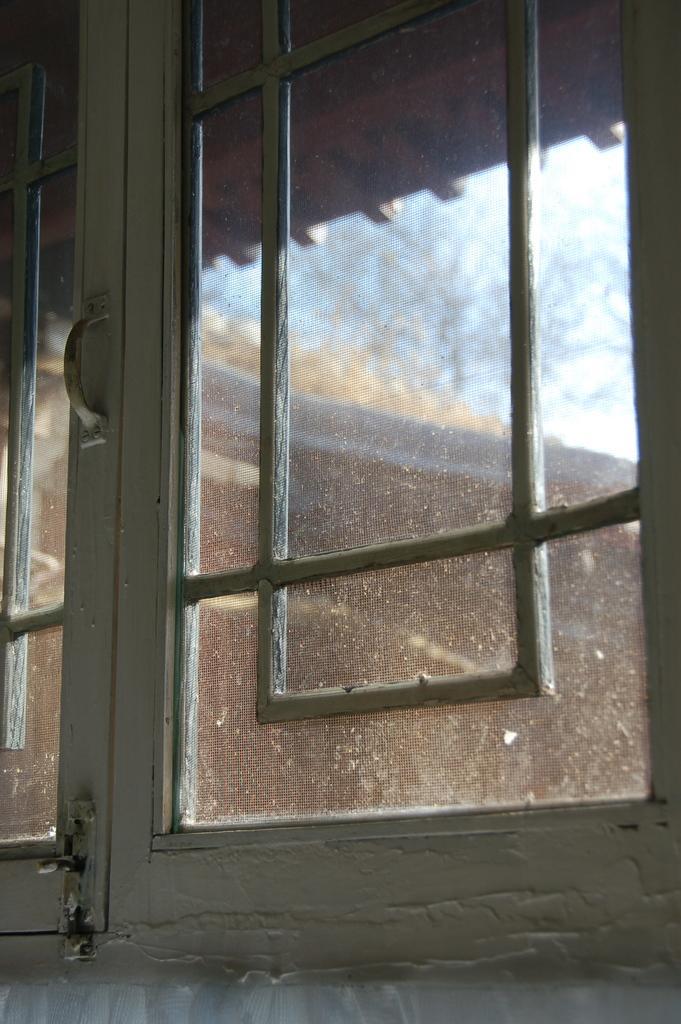In one or two sentences, can you explain what this image depicts? This is a zoomed in picture. In the foreground we can see the window and through the window we can see the sky and a building. 